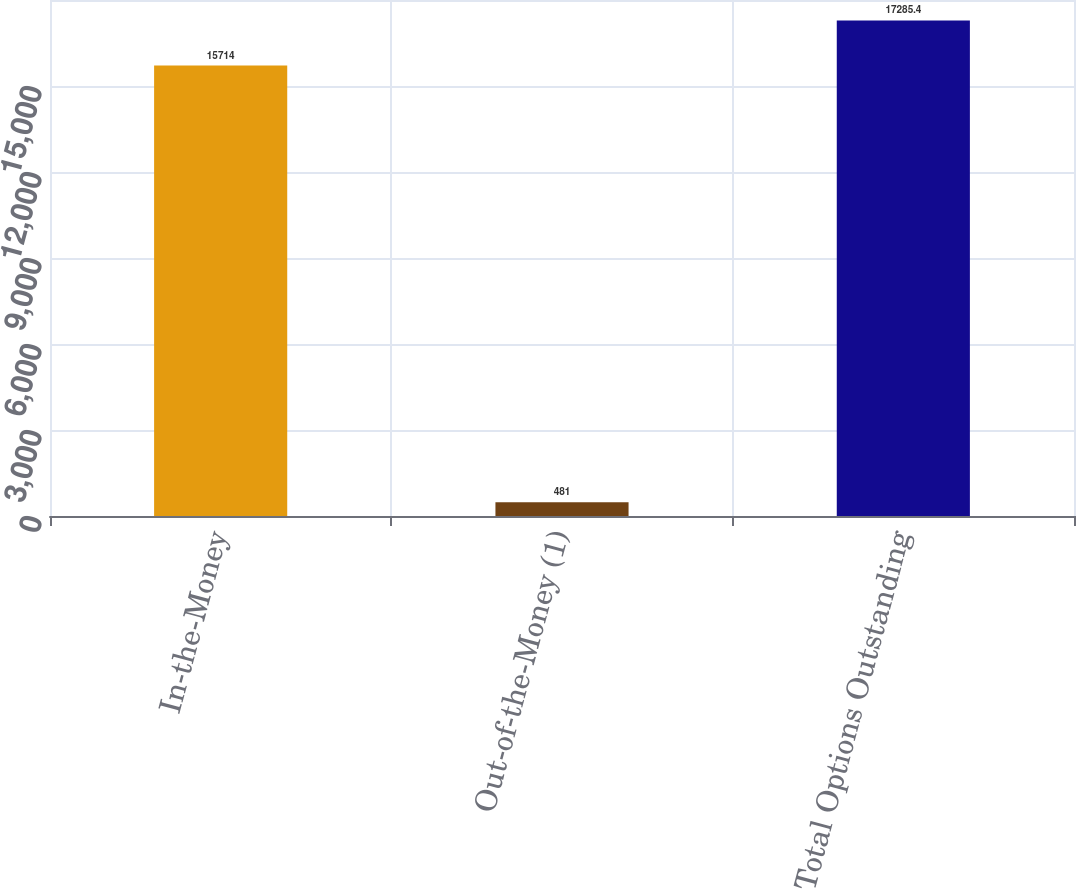Convert chart to OTSL. <chart><loc_0><loc_0><loc_500><loc_500><bar_chart><fcel>In-the-Money<fcel>Out-of-the-Money (1)<fcel>Total Options Outstanding<nl><fcel>15714<fcel>481<fcel>17285.4<nl></chart> 